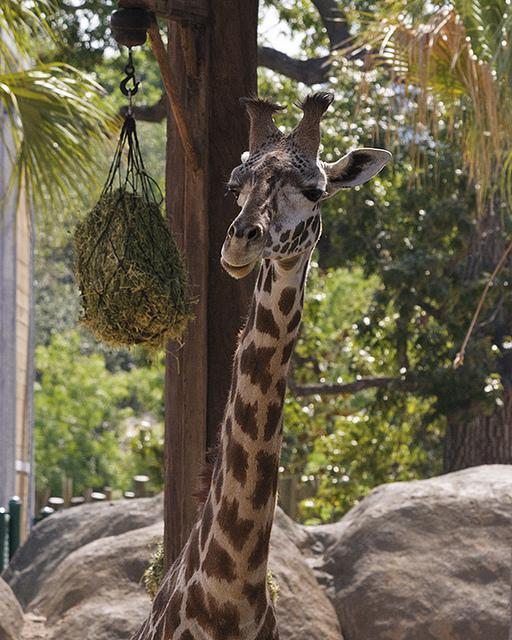How many people are wearing blue shirts?
Give a very brief answer. 0. 